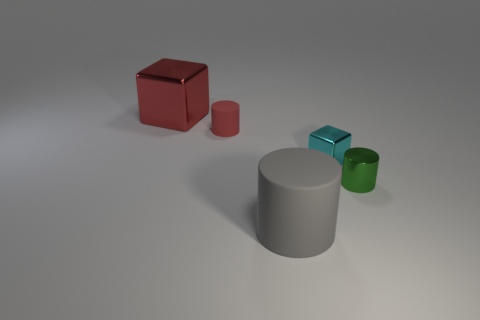There is a big metal block; is its color the same as the small object on the left side of the large cylinder?
Keep it short and to the point. Yes. Is the color of the small rubber thing right of the large metallic cube the same as the big block?
Provide a succinct answer. Yes. Does the large shiny block have the same color as the small matte object?
Keep it short and to the point. Yes. How many tiny rubber objects have the same color as the large shiny object?
Ensure brevity in your answer.  1. What material is the cylinder that is the same color as the big metal thing?
Offer a terse response. Rubber. What is the small cylinder that is to the left of the big gray rubber thing made of?
Make the answer very short. Rubber. Are the object left of the small rubber object and the green cylinder made of the same material?
Provide a short and direct response. Yes. What number of things are large yellow shiny cylinders or objects on the left side of the gray rubber cylinder?
Provide a succinct answer. 2. There is another metallic thing that is the same shape as the big red thing; what is its size?
Ensure brevity in your answer.  Small. Is there anything else that is the same size as the cyan object?
Your response must be concise. Yes. 